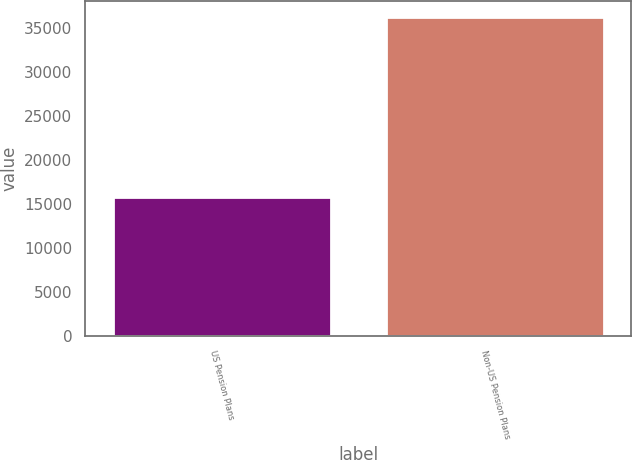<chart> <loc_0><loc_0><loc_500><loc_500><bar_chart><fcel>US Pension Plans<fcel>Non-US Pension Plans<nl><fcel>15781<fcel>36246<nl></chart> 